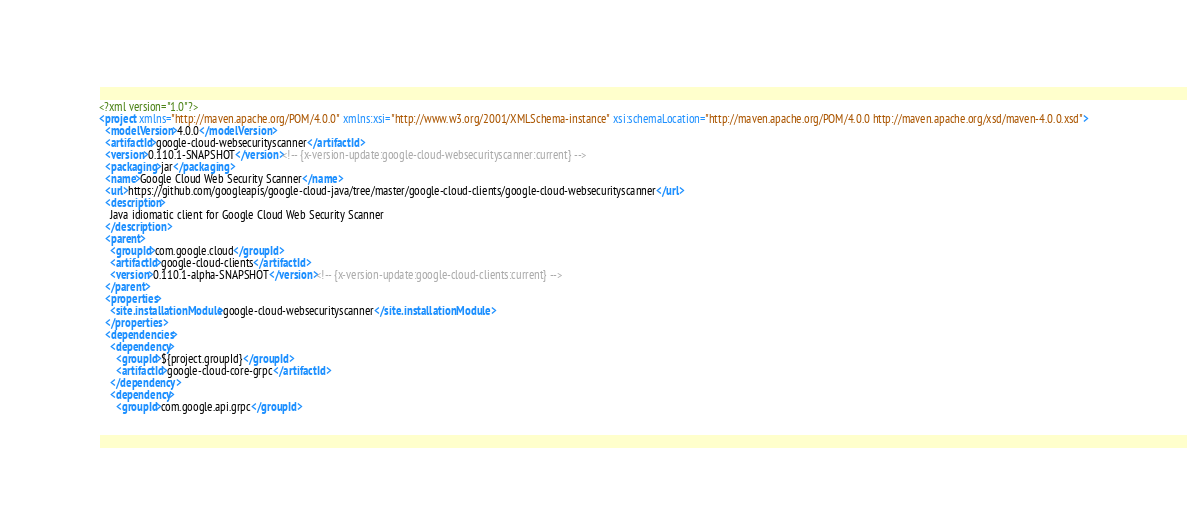Convert code to text. <code><loc_0><loc_0><loc_500><loc_500><_XML_><?xml version="1.0"?>
<project xmlns="http://maven.apache.org/POM/4.0.0" xmlns:xsi="http://www.w3.org/2001/XMLSchema-instance" xsi:schemaLocation="http://maven.apache.org/POM/4.0.0 http://maven.apache.org/xsd/maven-4.0.0.xsd">
  <modelVersion>4.0.0</modelVersion>
  <artifactId>google-cloud-websecurityscanner</artifactId>
  <version>0.110.1-SNAPSHOT</version><!-- {x-version-update:google-cloud-websecurityscanner:current} -->
  <packaging>jar</packaging>
  <name>Google Cloud Web Security Scanner</name>
  <url>https://github.com/googleapis/google-cloud-java/tree/master/google-cloud-clients/google-cloud-websecurityscanner</url>
  <description>
    Java idiomatic client for Google Cloud Web Security Scanner
  </description>
  <parent>
    <groupId>com.google.cloud</groupId>
    <artifactId>google-cloud-clients</artifactId>
    <version>0.110.1-alpha-SNAPSHOT</version><!-- {x-version-update:google-cloud-clients:current} -->
  </parent>
  <properties>
    <site.installationModule>google-cloud-websecurityscanner</site.installationModule>
  </properties>
  <dependencies>
    <dependency>
      <groupId>${project.groupId}</groupId>
      <artifactId>google-cloud-core-grpc</artifactId>
    </dependency>
    <dependency>
      <groupId>com.google.api.grpc</groupId></code> 